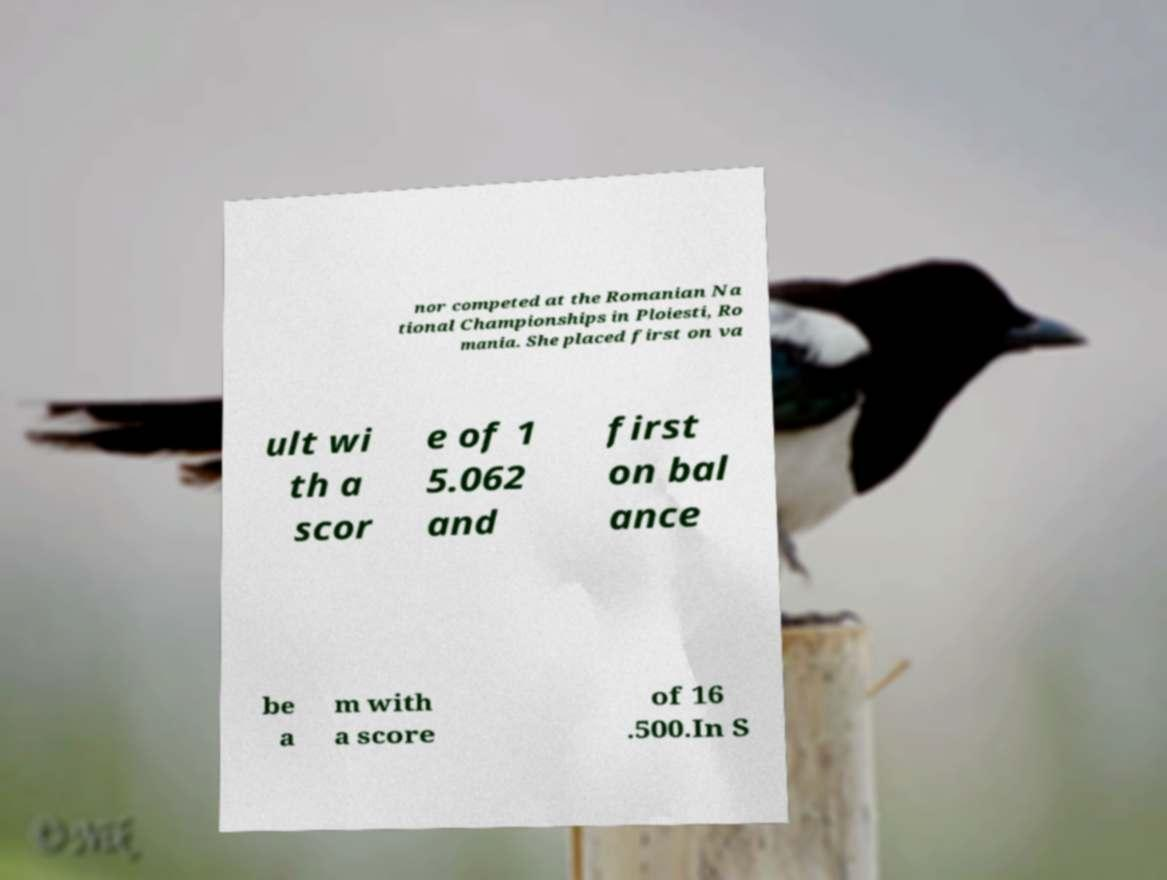Can you accurately transcribe the text from the provided image for me? nor competed at the Romanian Na tional Championships in Ploiesti, Ro mania. She placed first on va ult wi th a scor e of 1 5.062 and first on bal ance be a m with a score of 16 .500.In S 